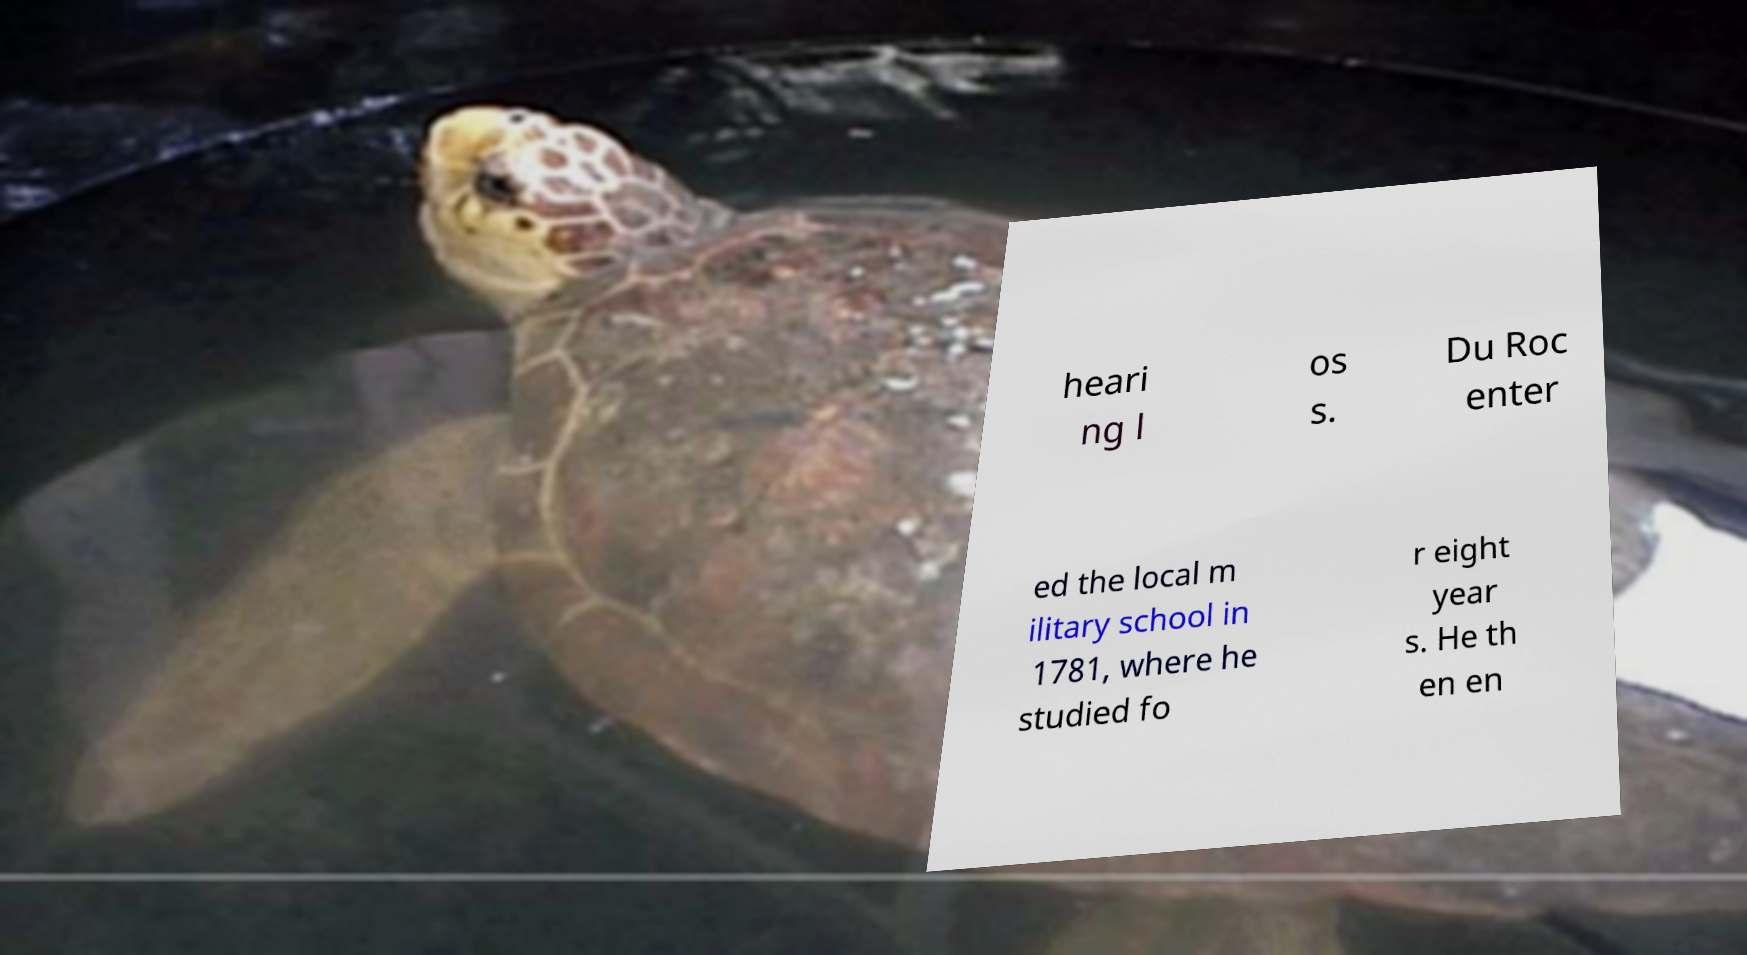Please read and relay the text visible in this image. What does it say? heari ng l os s. Du Roc enter ed the local m ilitary school in 1781, where he studied fo r eight year s. He th en en 